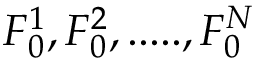Convert formula to latex. <formula><loc_0><loc_0><loc_500><loc_500>F _ { 0 } ^ { 1 } , F _ { 0 } ^ { 2 } , \cdots . , F _ { 0 } ^ { N }</formula> 